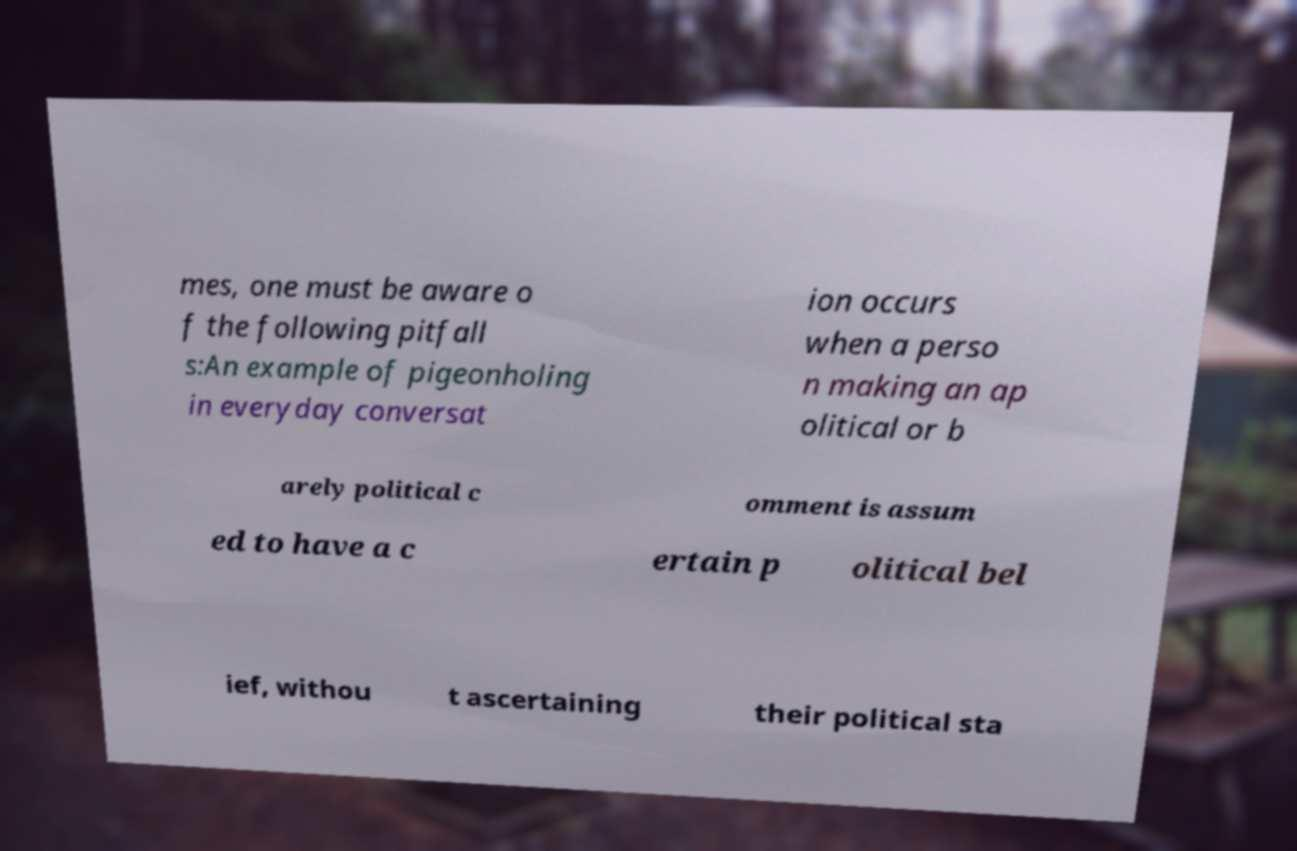For documentation purposes, I need the text within this image transcribed. Could you provide that? mes, one must be aware o f the following pitfall s:An example of pigeonholing in everyday conversat ion occurs when a perso n making an ap olitical or b arely political c omment is assum ed to have a c ertain p olitical bel ief, withou t ascertaining their political sta 